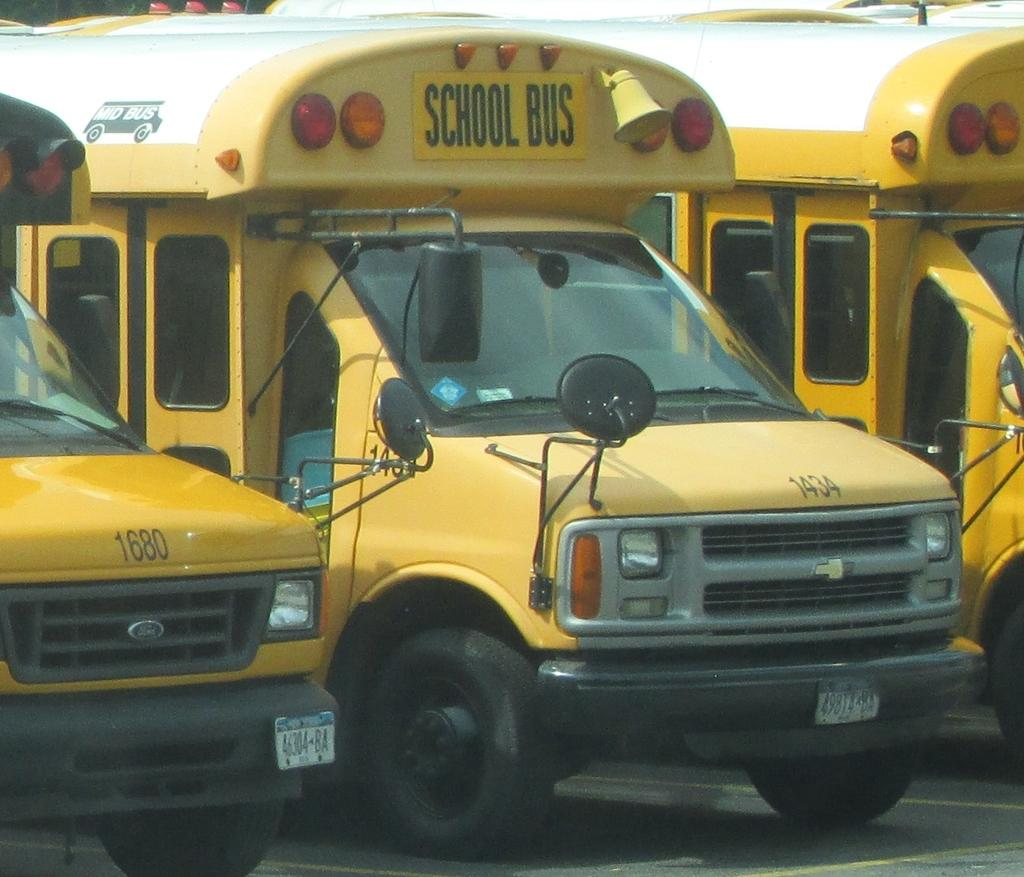<image>
Render a clear and concise summary of the photo. Three short yellow school busses are parked next to each other. 